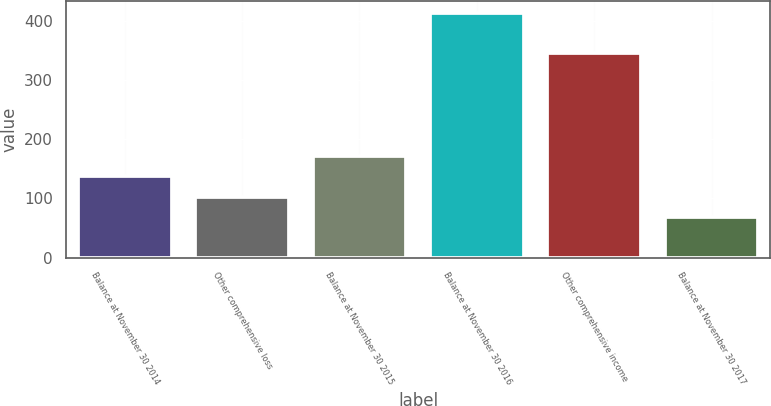Convert chart. <chart><loc_0><loc_0><loc_500><loc_500><bar_chart><fcel>Balance at November 30 2014<fcel>Other comprehensive loss<fcel>Balance at November 30 2015<fcel>Balance at November 30 2016<fcel>Other comprehensive income<fcel>Balance at November 30 2017<nl><fcel>137.26<fcel>102.68<fcel>171.84<fcel>413.9<fcel>345.8<fcel>68.1<nl></chart> 